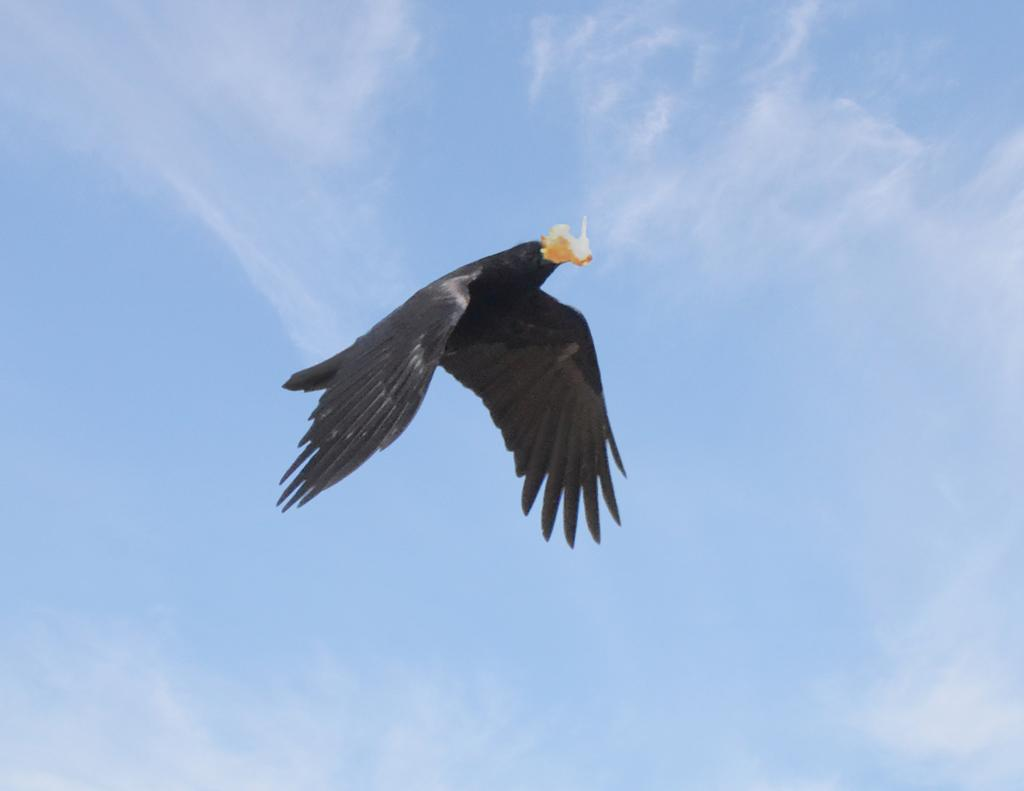What type of animal is present in the image? There is a bird in the image. What is the color of the bird? The bird is black in color. What is the bird doing in the image? The bird is flying in the sky. What is the bird holding in its beak? The bird is holding something with its beak. What can be seen in the background of the image? The sky is visible in the background of the image. What is the color of the sky in the image? The sky is blue in color. What historical event is the bird commemorating in the image? There is no indication of a historical event in the image; it simply shows a black bird flying in the sky. Does the bird have a brother in the image? There is no mention of a brother or any other bird in the image. 